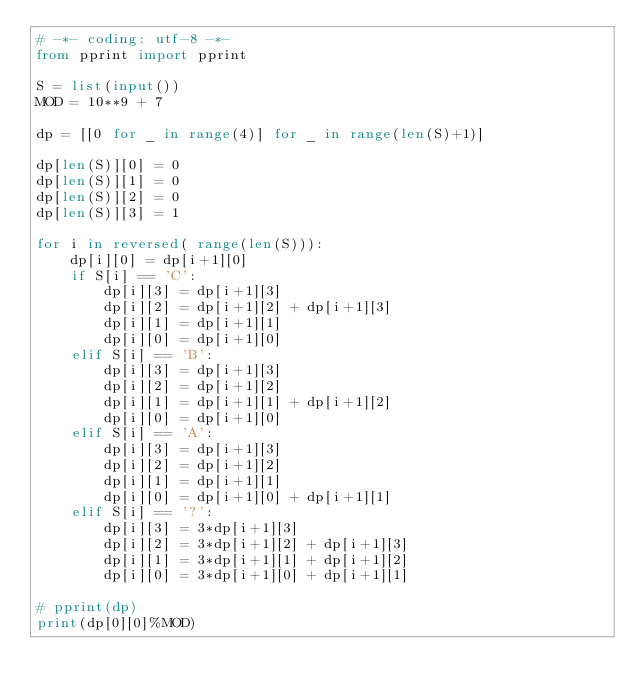<code> <loc_0><loc_0><loc_500><loc_500><_Python_># -*- coding: utf-8 -*-
from pprint import pprint

S = list(input())
MOD = 10**9 + 7

dp = [[0 for _ in range(4)] for _ in range(len(S)+1)]

dp[len(S)][0] = 0
dp[len(S)][1] = 0
dp[len(S)][2] = 0
dp[len(S)][3] = 1

for i in reversed( range(len(S))):
    dp[i][0] = dp[i+1][0]
    if S[i] == 'C':
        dp[i][3] = dp[i+1][3]
        dp[i][2] = dp[i+1][2] + dp[i+1][3]
        dp[i][1] = dp[i+1][1] 
        dp[i][0] = dp[i+1][0]
    elif S[i] == 'B':
        dp[i][3] = dp[i+1][3]
        dp[i][2] = dp[i+1][2]
        dp[i][1] = dp[i+1][1] + dp[i+1][2]
        dp[i][0] = dp[i+1][0]
    elif S[i] == 'A':
        dp[i][3] = dp[i+1][3]
        dp[i][2] = dp[i+1][2] 
        dp[i][1] = dp[i+1][1] 
        dp[i][0] = dp[i+1][0] + dp[i+1][1]
    elif S[i] == '?':
        dp[i][3] = 3*dp[i+1][3]
        dp[i][2] = 3*dp[i+1][2] + dp[i+1][3]
        dp[i][1] = 3*dp[i+1][1] + dp[i+1][2]
        dp[i][0] = 3*dp[i+1][0] + dp[i+1][1]

# pprint(dp)
print(dp[0][0]%MOD)
</code> 